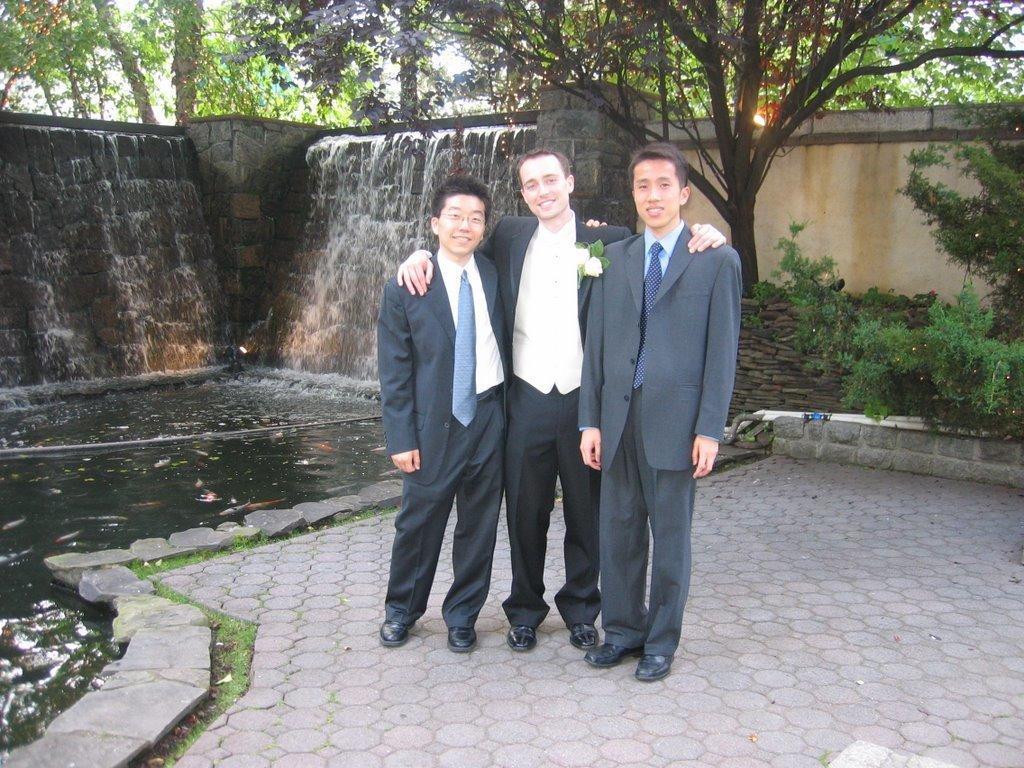Could you give a brief overview of what you see in this image? In this image in the center there are persons standing and smiling. In the background there are trees, and in the center there is water. 